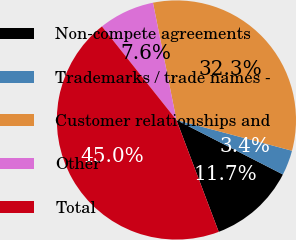<chart> <loc_0><loc_0><loc_500><loc_500><pie_chart><fcel>Non-compete agreements<fcel>Trademarks / trade names -<fcel>Customer relationships and<fcel>Other<fcel>Total<nl><fcel>11.72%<fcel>3.39%<fcel>32.28%<fcel>7.56%<fcel>45.05%<nl></chart> 